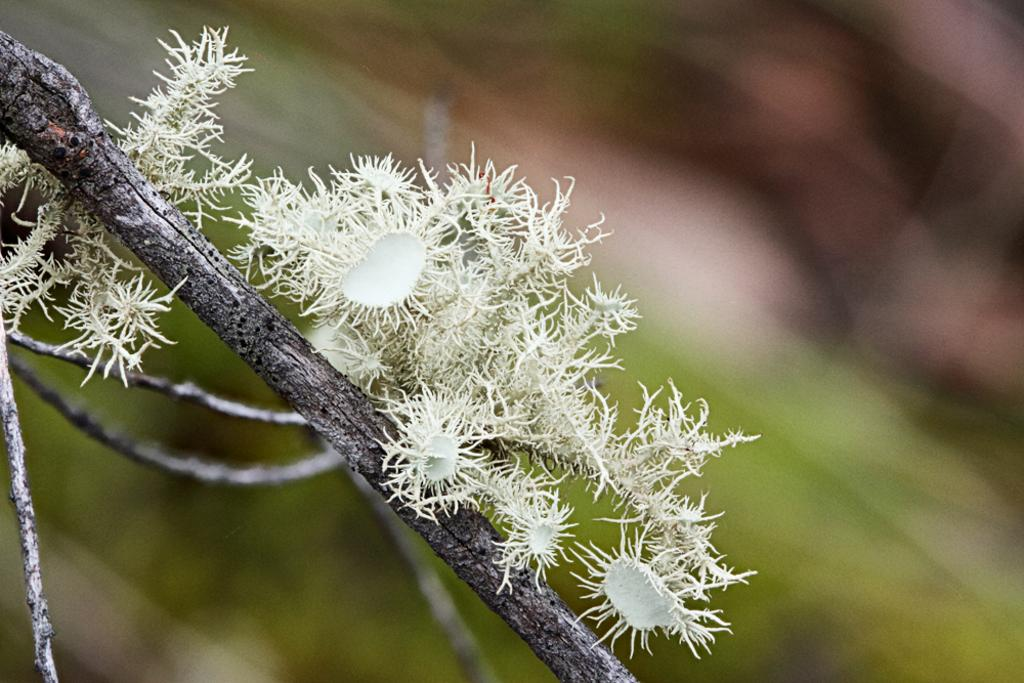What is the color of the objects on the branch of the tree in the image? The objects on the branch of the tree are white. Can you describe the background of the image? The background of the image is blurred. What type of cart can be seen in the image? There is no cart present in the image. How many circles are visible in the image? There are no circles visible in the image. 